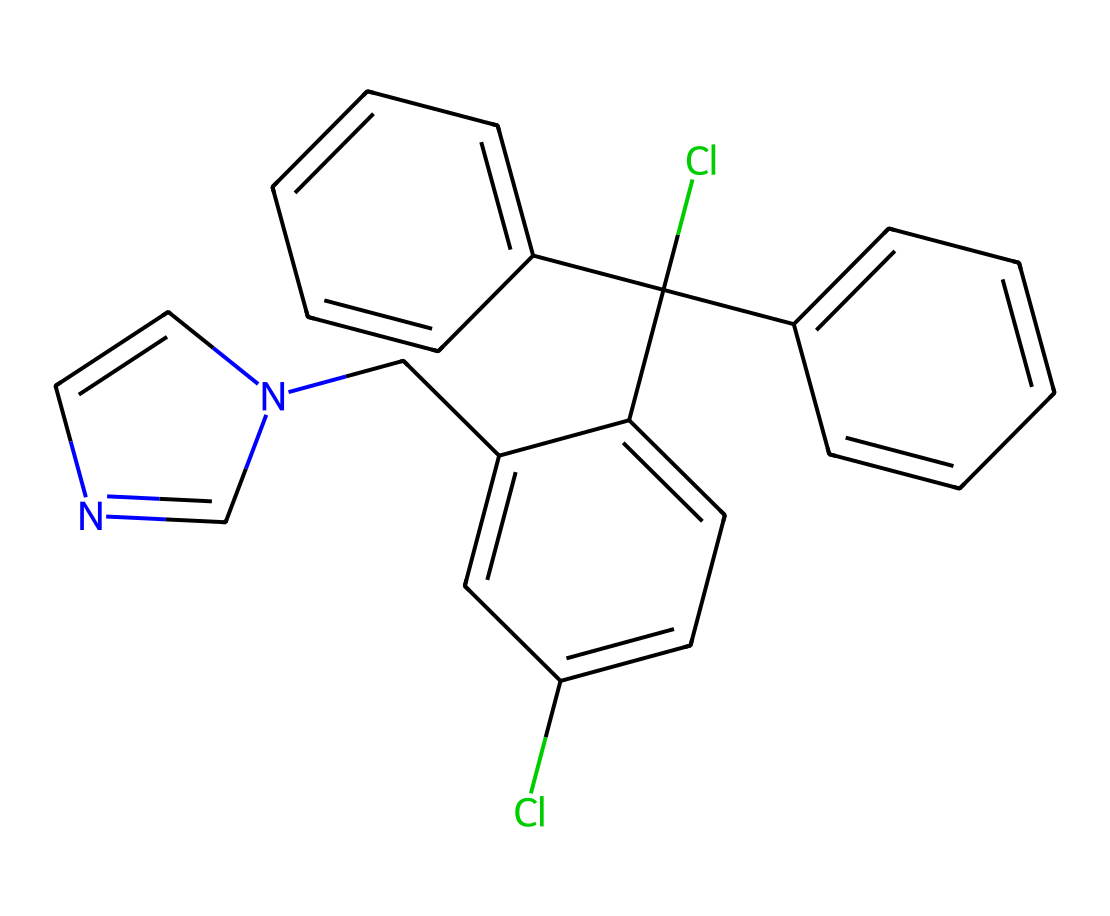What is the molecular formula of clotrimazole? To determine the molecular formula from the SMILES representation, we need to count the number of each type of atom present. The SMILES includes chlorine (Cl), carbon (C), nitrogen (N), and hydrogen (H). After analyzing the structure, we find that there are 22 carbon atoms, 19 hydrogen atoms, 2 chlorine atoms, and 2 nitrogen atoms, which leads to the molecular formula C22H17Cl2N2.
Answer: C22H17Cl2N2 How many nitrogen atoms are in clotrimazole? Counting the nitrogen atoms in the structure, we can see there are two nitrogen atoms represented, which can be observed as part of the imidazole ring.
Answer: 2 What functional groups are present in clotrimazole? By looking at the chemical structure, we can identify specific functional groups, such as the imidazole ring that contains nitrogen atoms, and the presence of chloro groups (attached Cl atoms). The combination of these functional groups contributes to the antifungal activity.
Answer: imidazole and chloro groups What type of compound is clotrimazole classified as? Clotrimazole is primarily used as a topical antifungal agent, so it can be classified in the category of antifungal substances. Its structure indicates that it belongs to the class of azoles, which are known fungicides due to their mechanism of action against fungal cell membranes.
Answer: antifungal What is the main mechanism of action of clotrimazole according to its structure? Clotrimazole works by inhibiting the synthesis of ergosterol, a vital component of the fungal cell membrane. The presence of the imidazole ring in its structure suggests it interferes with the enzyme (lanosterol demethylase) involved in this biosynthesis, thus providing its antifungal effects.
Answer: inhibits ergosterol synthesis How many rings are present in the structure of clotrimazole? A close examination of the structure reveals that clotrimazole has two distinct rings: one is the imidazole ring, and the other is a phenyl group, contributing to its complex ring system that is critical for its biological activity.
Answer: 2 